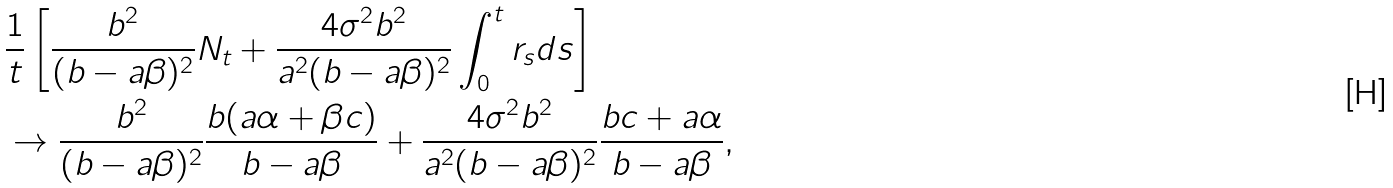Convert formula to latex. <formula><loc_0><loc_0><loc_500><loc_500>& \frac { 1 } { t } \left [ \frac { b ^ { 2 } } { ( b - a \beta ) ^ { 2 } } N _ { t } + \frac { 4 \sigma ^ { 2 } b ^ { 2 } } { a ^ { 2 } ( b - a \beta ) ^ { 2 } } \int _ { 0 } ^ { t } r _ { s } d s \right ] \\ & \rightarrow \frac { b ^ { 2 } } { ( b - a \beta ) ^ { 2 } } \frac { b ( a \alpha + \beta c ) } { b - a \beta } + \frac { 4 \sigma ^ { 2 } b ^ { 2 } } { a ^ { 2 } ( b - a \beta ) ^ { 2 } } \frac { b c + a \alpha } { b - a \beta } ,</formula> 